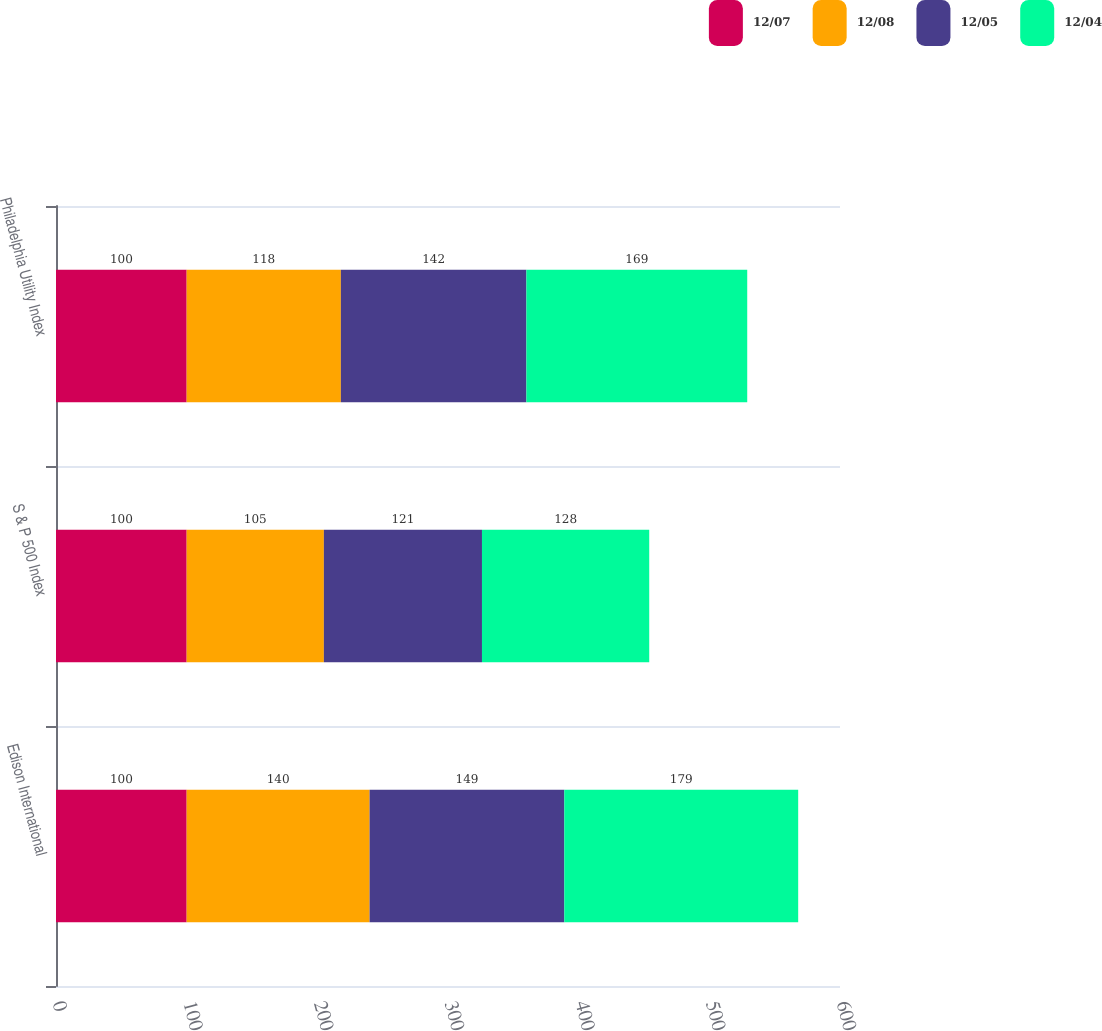Convert chart to OTSL. <chart><loc_0><loc_0><loc_500><loc_500><stacked_bar_chart><ecel><fcel>Edison International<fcel>S & P 500 Index<fcel>Philadelphia Utility Index<nl><fcel>12/07<fcel>100<fcel>100<fcel>100<nl><fcel>12/08<fcel>140<fcel>105<fcel>118<nl><fcel>12/05<fcel>149<fcel>121<fcel>142<nl><fcel>12/04<fcel>179<fcel>128<fcel>169<nl></chart> 